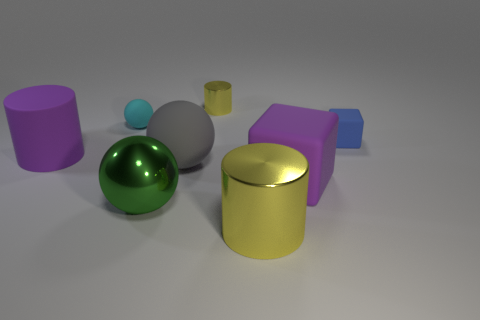What shape is the other object that is the same color as the tiny metallic object?
Make the answer very short. Cylinder. Is the shape of the big purple thing left of the big purple block the same as  the big gray object?
Your response must be concise. No. Are there any tiny green metal things?
Offer a terse response. No. What color is the small metallic cylinder that is behind the tiny matte object that is on the left side of the metal cylinder behind the small blue rubber thing?
Provide a short and direct response. Yellow. Are there the same number of tiny cyan spheres to the right of the big matte sphere and yellow cylinders that are behind the big green thing?
Ensure brevity in your answer.  No. There is a cyan object that is the same size as the blue object; what shape is it?
Make the answer very short. Sphere. Are there any matte things of the same color as the big matte cylinder?
Provide a short and direct response. Yes. What is the shape of the small rubber thing to the right of the purple rubber block?
Your response must be concise. Cube. What color is the large shiny cylinder?
Ensure brevity in your answer.  Yellow. What color is the big cylinder that is the same material as the big gray sphere?
Keep it short and to the point. Purple. 